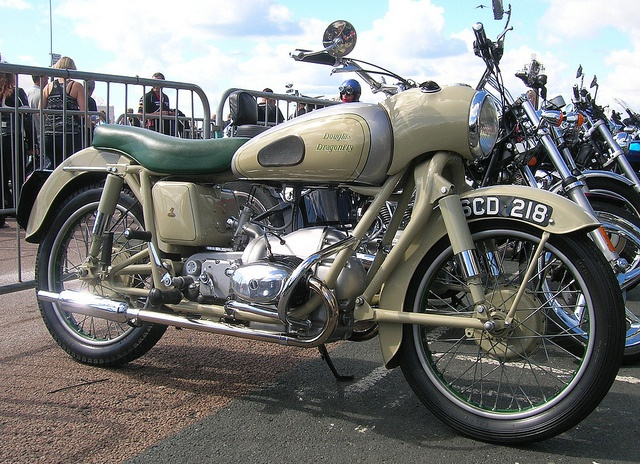Describe the objects in this image and their specific colors. I can see motorcycle in white, black, gray, and darkgray tones, motorcycle in white, black, gray, and darkgray tones, people in white, black, gray, and darkgray tones, motorcycle in white, black, and gray tones, and people in white, black, and gray tones in this image. 